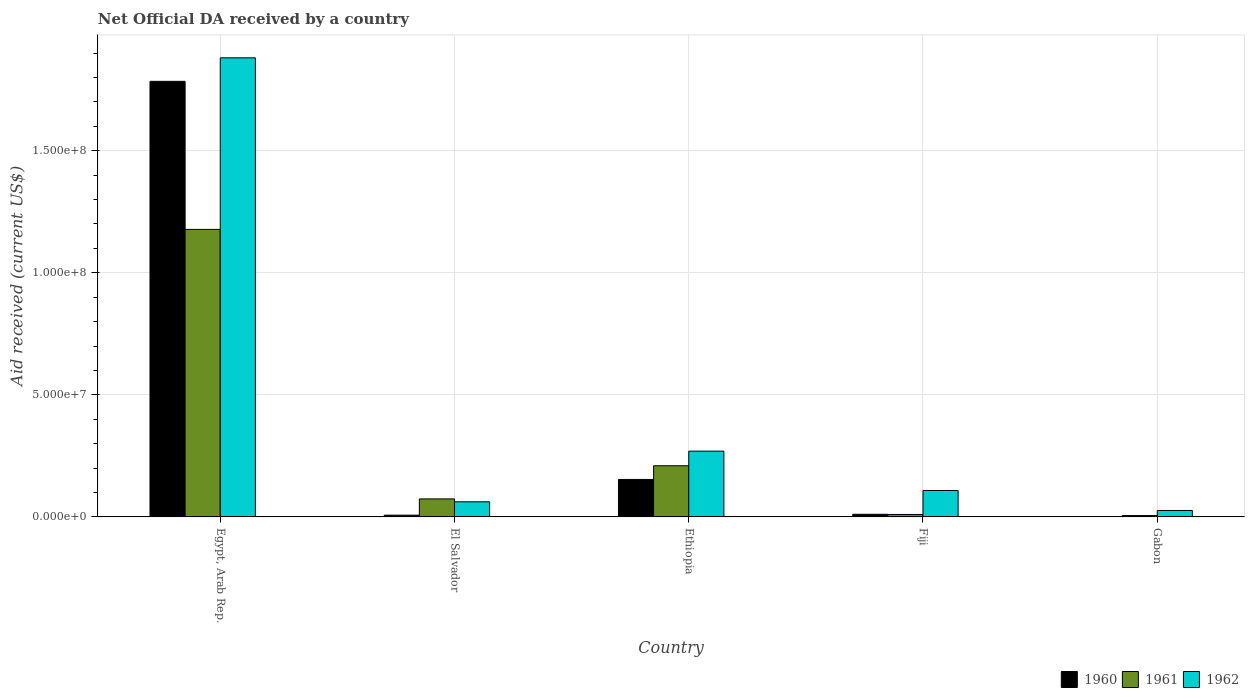Are the number of bars per tick equal to the number of legend labels?
Your answer should be compact. Yes. Are the number of bars on each tick of the X-axis equal?
Make the answer very short. Yes. How many bars are there on the 1st tick from the left?
Your response must be concise. 3. How many bars are there on the 5th tick from the right?
Your answer should be compact. 3. What is the label of the 5th group of bars from the left?
Make the answer very short. Gabon. In how many cases, is the number of bars for a given country not equal to the number of legend labels?
Provide a succinct answer. 0. What is the net official development assistance aid received in 1960 in Ethiopia?
Provide a short and direct response. 1.54e+07. Across all countries, what is the maximum net official development assistance aid received in 1960?
Provide a succinct answer. 1.78e+08. Across all countries, what is the minimum net official development assistance aid received in 1962?
Ensure brevity in your answer.  2.64e+06. In which country was the net official development assistance aid received in 1962 maximum?
Ensure brevity in your answer.  Egypt, Arab Rep. In which country was the net official development assistance aid received in 1960 minimum?
Your answer should be very brief. Gabon. What is the total net official development assistance aid received in 1961 in the graph?
Your answer should be compact. 1.48e+08. What is the difference between the net official development assistance aid received in 1961 in El Salvador and that in Ethiopia?
Your answer should be very brief. -1.36e+07. What is the difference between the net official development assistance aid received in 1960 in Gabon and the net official development assistance aid received in 1962 in El Salvador?
Provide a succinct answer. -6.17e+06. What is the average net official development assistance aid received in 1960 per country?
Give a very brief answer. 3.91e+07. What is the difference between the net official development assistance aid received of/in 1962 and net official development assistance aid received of/in 1960 in Ethiopia?
Your answer should be compact. 1.16e+07. What is the ratio of the net official development assistance aid received in 1962 in El Salvador to that in Ethiopia?
Your response must be concise. 0.23. Is the net official development assistance aid received in 1960 in Egypt, Arab Rep. less than that in Ethiopia?
Keep it short and to the point. No. What is the difference between the highest and the second highest net official development assistance aid received in 1960?
Give a very brief answer. 1.77e+08. What is the difference between the highest and the lowest net official development assistance aid received in 1962?
Offer a very short reply. 1.85e+08. In how many countries, is the net official development assistance aid received in 1960 greater than the average net official development assistance aid received in 1960 taken over all countries?
Ensure brevity in your answer.  1. What does the 2nd bar from the left in Ethiopia represents?
Keep it short and to the point. 1961. Is it the case that in every country, the sum of the net official development assistance aid received in 1961 and net official development assistance aid received in 1962 is greater than the net official development assistance aid received in 1960?
Your response must be concise. Yes. How many bars are there?
Keep it short and to the point. 15. Are all the bars in the graph horizontal?
Your answer should be compact. No. How many countries are there in the graph?
Make the answer very short. 5. Where does the legend appear in the graph?
Offer a terse response. Bottom right. How are the legend labels stacked?
Ensure brevity in your answer.  Horizontal. What is the title of the graph?
Make the answer very short. Net Official DA received by a country. What is the label or title of the Y-axis?
Provide a succinct answer. Aid received (current US$). What is the Aid received (current US$) of 1960 in Egypt, Arab Rep.?
Ensure brevity in your answer.  1.78e+08. What is the Aid received (current US$) of 1961 in Egypt, Arab Rep.?
Provide a succinct answer. 1.18e+08. What is the Aid received (current US$) of 1962 in Egypt, Arab Rep.?
Provide a succinct answer. 1.88e+08. What is the Aid received (current US$) in 1960 in El Salvador?
Make the answer very short. 7.20e+05. What is the Aid received (current US$) of 1961 in El Salvador?
Your answer should be compact. 7.38e+06. What is the Aid received (current US$) of 1962 in El Salvador?
Keep it short and to the point. 6.19e+06. What is the Aid received (current US$) of 1960 in Ethiopia?
Provide a succinct answer. 1.54e+07. What is the Aid received (current US$) in 1961 in Ethiopia?
Keep it short and to the point. 2.10e+07. What is the Aid received (current US$) in 1962 in Ethiopia?
Keep it short and to the point. 2.69e+07. What is the Aid received (current US$) of 1960 in Fiji?
Keep it short and to the point. 1.08e+06. What is the Aid received (current US$) of 1961 in Fiji?
Ensure brevity in your answer.  1.01e+06. What is the Aid received (current US$) in 1962 in Fiji?
Keep it short and to the point. 1.08e+07. What is the Aid received (current US$) of 1960 in Gabon?
Give a very brief answer. 2.00e+04. What is the Aid received (current US$) in 1961 in Gabon?
Offer a very short reply. 5.60e+05. What is the Aid received (current US$) of 1962 in Gabon?
Your answer should be compact. 2.64e+06. Across all countries, what is the maximum Aid received (current US$) in 1960?
Ensure brevity in your answer.  1.78e+08. Across all countries, what is the maximum Aid received (current US$) in 1961?
Provide a succinct answer. 1.18e+08. Across all countries, what is the maximum Aid received (current US$) in 1962?
Offer a terse response. 1.88e+08. Across all countries, what is the minimum Aid received (current US$) of 1960?
Keep it short and to the point. 2.00e+04. Across all countries, what is the minimum Aid received (current US$) of 1961?
Make the answer very short. 5.60e+05. Across all countries, what is the minimum Aid received (current US$) in 1962?
Your answer should be compact. 2.64e+06. What is the total Aid received (current US$) in 1960 in the graph?
Your answer should be very brief. 1.96e+08. What is the total Aid received (current US$) of 1961 in the graph?
Give a very brief answer. 1.48e+08. What is the total Aid received (current US$) of 1962 in the graph?
Provide a short and direct response. 2.35e+08. What is the difference between the Aid received (current US$) of 1960 in Egypt, Arab Rep. and that in El Salvador?
Give a very brief answer. 1.78e+08. What is the difference between the Aid received (current US$) in 1961 in Egypt, Arab Rep. and that in El Salvador?
Your answer should be compact. 1.10e+08. What is the difference between the Aid received (current US$) in 1962 in Egypt, Arab Rep. and that in El Salvador?
Provide a short and direct response. 1.82e+08. What is the difference between the Aid received (current US$) in 1960 in Egypt, Arab Rep. and that in Ethiopia?
Give a very brief answer. 1.63e+08. What is the difference between the Aid received (current US$) of 1961 in Egypt, Arab Rep. and that in Ethiopia?
Ensure brevity in your answer.  9.68e+07. What is the difference between the Aid received (current US$) in 1962 in Egypt, Arab Rep. and that in Ethiopia?
Keep it short and to the point. 1.61e+08. What is the difference between the Aid received (current US$) of 1960 in Egypt, Arab Rep. and that in Fiji?
Provide a short and direct response. 1.77e+08. What is the difference between the Aid received (current US$) of 1961 in Egypt, Arab Rep. and that in Fiji?
Offer a very short reply. 1.17e+08. What is the difference between the Aid received (current US$) of 1962 in Egypt, Arab Rep. and that in Fiji?
Keep it short and to the point. 1.77e+08. What is the difference between the Aid received (current US$) of 1960 in Egypt, Arab Rep. and that in Gabon?
Your response must be concise. 1.78e+08. What is the difference between the Aid received (current US$) of 1961 in Egypt, Arab Rep. and that in Gabon?
Make the answer very short. 1.17e+08. What is the difference between the Aid received (current US$) of 1962 in Egypt, Arab Rep. and that in Gabon?
Keep it short and to the point. 1.85e+08. What is the difference between the Aid received (current US$) in 1960 in El Salvador and that in Ethiopia?
Your response must be concise. -1.46e+07. What is the difference between the Aid received (current US$) of 1961 in El Salvador and that in Ethiopia?
Offer a terse response. -1.36e+07. What is the difference between the Aid received (current US$) in 1962 in El Salvador and that in Ethiopia?
Ensure brevity in your answer.  -2.08e+07. What is the difference between the Aid received (current US$) in 1960 in El Salvador and that in Fiji?
Provide a succinct answer. -3.60e+05. What is the difference between the Aid received (current US$) of 1961 in El Salvador and that in Fiji?
Give a very brief answer. 6.37e+06. What is the difference between the Aid received (current US$) of 1962 in El Salvador and that in Fiji?
Ensure brevity in your answer.  -4.63e+06. What is the difference between the Aid received (current US$) in 1960 in El Salvador and that in Gabon?
Your answer should be compact. 7.00e+05. What is the difference between the Aid received (current US$) of 1961 in El Salvador and that in Gabon?
Make the answer very short. 6.82e+06. What is the difference between the Aid received (current US$) in 1962 in El Salvador and that in Gabon?
Provide a short and direct response. 3.55e+06. What is the difference between the Aid received (current US$) in 1960 in Ethiopia and that in Fiji?
Make the answer very short. 1.43e+07. What is the difference between the Aid received (current US$) of 1961 in Ethiopia and that in Fiji?
Your answer should be very brief. 2.00e+07. What is the difference between the Aid received (current US$) in 1962 in Ethiopia and that in Fiji?
Make the answer very short. 1.61e+07. What is the difference between the Aid received (current US$) of 1960 in Ethiopia and that in Gabon?
Your response must be concise. 1.53e+07. What is the difference between the Aid received (current US$) in 1961 in Ethiopia and that in Gabon?
Keep it short and to the point. 2.04e+07. What is the difference between the Aid received (current US$) of 1962 in Ethiopia and that in Gabon?
Your answer should be compact. 2.43e+07. What is the difference between the Aid received (current US$) of 1960 in Fiji and that in Gabon?
Provide a short and direct response. 1.06e+06. What is the difference between the Aid received (current US$) of 1962 in Fiji and that in Gabon?
Give a very brief answer. 8.18e+06. What is the difference between the Aid received (current US$) in 1960 in Egypt, Arab Rep. and the Aid received (current US$) in 1961 in El Salvador?
Provide a short and direct response. 1.71e+08. What is the difference between the Aid received (current US$) in 1960 in Egypt, Arab Rep. and the Aid received (current US$) in 1962 in El Salvador?
Offer a terse response. 1.72e+08. What is the difference between the Aid received (current US$) in 1961 in Egypt, Arab Rep. and the Aid received (current US$) in 1962 in El Salvador?
Provide a succinct answer. 1.12e+08. What is the difference between the Aid received (current US$) in 1960 in Egypt, Arab Rep. and the Aid received (current US$) in 1961 in Ethiopia?
Offer a terse response. 1.57e+08. What is the difference between the Aid received (current US$) of 1960 in Egypt, Arab Rep. and the Aid received (current US$) of 1962 in Ethiopia?
Ensure brevity in your answer.  1.51e+08. What is the difference between the Aid received (current US$) of 1961 in Egypt, Arab Rep. and the Aid received (current US$) of 1962 in Ethiopia?
Offer a very short reply. 9.08e+07. What is the difference between the Aid received (current US$) of 1960 in Egypt, Arab Rep. and the Aid received (current US$) of 1961 in Fiji?
Keep it short and to the point. 1.77e+08. What is the difference between the Aid received (current US$) of 1960 in Egypt, Arab Rep. and the Aid received (current US$) of 1962 in Fiji?
Ensure brevity in your answer.  1.68e+08. What is the difference between the Aid received (current US$) of 1961 in Egypt, Arab Rep. and the Aid received (current US$) of 1962 in Fiji?
Keep it short and to the point. 1.07e+08. What is the difference between the Aid received (current US$) of 1960 in Egypt, Arab Rep. and the Aid received (current US$) of 1961 in Gabon?
Your answer should be very brief. 1.78e+08. What is the difference between the Aid received (current US$) in 1960 in Egypt, Arab Rep. and the Aid received (current US$) in 1962 in Gabon?
Provide a succinct answer. 1.76e+08. What is the difference between the Aid received (current US$) of 1961 in Egypt, Arab Rep. and the Aid received (current US$) of 1962 in Gabon?
Keep it short and to the point. 1.15e+08. What is the difference between the Aid received (current US$) of 1960 in El Salvador and the Aid received (current US$) of 1961 in Ethiopia?
Offer a terse response. -2.02e+07. What is the difference between the Aid received (current US$) in 1960 in El Salvador and the Aid received (current US$) in 1962 in Ethiopia?
Your answer should be compact. -2.62e+07. What is the difference between the Aid received (current US$) in 1961 in El Salvador and the Aid received (current US$) in 1962 in Ethiopia?
Offer a terse response. -1.96e+07. What is the difference between the Aid received (current US$) in 1960 in El Salvador and the Aid received (current US$) in 1962 in Fiji?
Provide a short and direct response. -1.01e+07. What is the difference between the Aid received (current US$) of 1961 in El Salvador and the Aid received (current US$) of 1962 in Fiji?
Offer a terse response. -3.44e+06. What is the difference between the Aid received (current US$) of 1960 in El Salvador and the Aid received (current US$) of 1962 in Gabon?
Keep it short and to the point. -1.92e+06. What is the difference between the Aid received (current US$) of 1961 in El Salvador and the Aid received (current US$) of 1962 in Gabon?
Offer a terse response. 4.74e+06. What is the difference between the Aid received (current US$) of 1960 in Ethiopia and the Aid received (current US$) of 1961 in Fiji?
Offer a terse response. 1.43e+07. What is the difference between the Aid received (current US$) in 1960 in Ethiopia and the Aid received (current US$) in 1962 in Fiji?
Your answer should be compact. 4.53e+06. What is the difference between the Aid received (current US$) of 1961 in Ethiopia and the Aid received (current US$) of 1962 in Fiji?
Give a very brief answer. 1.01e+07. What is the difference between the Aid received (current US$) of 1960 in Ethiopia and the Aid received (current US$) of 1961 in Gabon?
Ensure brevity in your answer.  1.48e+07. What is the difference between the Aid received (current US$) of 1960 in Ethiopia and the Aid received (current US$) of 1962 in Gabon?
Ensure brevity in your answer.  1.27e+07. What is the difference between the Aid received (current US$) of 1961 in Ethiopia and the Aid received (current US$) of 1962 in Gabon?
Your response must be concise. 1.83e+07. What is the difference between the Aid received (current US$) in 1960 in Fiji and the Aid received (current US$) in 1961 in Gabon?
Offer a very short reply. 5.20e+05. What is the difference between the Aid received (current US$) in 1960 in Fiji and the Aid received (current US$) in 1962 in Gabon?
Provide a short and direct response. -1.56e+06. What is the difference between the Aid received (current US$) in 1961 in Fiji and the Aid received (current US$) in 1962 in Gabon?
Offer a terse response. -1.63e+06. What is the average Aid received (current US$) of 1960 per country?
Ensure brevity in your answer.  3.91e+07. What is the average Aid received (current US$) in 1961 per country?
Offer a terse response. 2.95e+07. What is the average Aid received (current US$) of 1962 per country?
Your response must be concise. 4.69e+07. What is the difference between the Aid received (current US$) in 1960 and Aid received (current US$) in 1961 in Egypt, Arab Rep.?
Give a very brief answer. 6.06e+07. What is the difference between the Aid received (current US$) in 1960 and Aid received (current US$) in 1962 in Egypt, Arab Rep.?
Ensure brevity in your answer.  -9.63e+06. What is the difference between the Aid received (current US$) in 1961 and Aid received (current US$) in 1962 in Egypt, Arab Rep.?
Make the answer very short. -7.03e+07. What is the difference between the Aid received (current US$) in 1960 and Aid received (current US$) in 1961 in El Salvador?
Give a very brief answer. -6.66e+06. What is the difference between the Aid received (current US$) of 1960 and Aid received (current US$) of 1962 in El Salvador?
Provide a short and direct response. -5.47e+06. What is the difference between the Aid received (current US$) of 1961 and Aid received (current US$) of 1962 in El Salvador?
Offer a terse response. 1.19e+06. What is the difference between the Aid received (current US$) in 1960 and Aid received (current US$) in 1961 in Ethiopia?
Make the answer very short. -5.61e+06. What is the difference between the Aid received (current US$) in 1960 and Aid received (current US$) in 1962 in Ethiopia?
Provide a short and direct response. -1.16e+07. What is the difference between the Aid received (current US$) of 1961 and Aid received (current US$) of 1962 in Ethiopia?
Keep it short and to the point. -5.98e+06. What is the difference between the Aid received (current US$) in 1960 and Aid received (current US$) in 1962 in Fiji?
Give a very brief answer. -9.74e+06. What is the difference between the Aid received (current US$) in 1961 and Aid received (current US$) in 1962 in Fiji?
Provide a short and direct response. -9.81e+06. What is the difference between the Aid received (current US$) of 1960 and Aid received (current US$) of 1961 in Gabon?
Your answer should be compact. -5.40e+05. What is the difference between the Aid received (current US$) in 1960 and Aid received (current US$) in 1962 in Gabon?
Keep it short and to the point. -2.62e+06. What is the difference between the Aid received (current US$) of 1961 and Aid received (current US$) of 1962 in Gabon?
Ensure brevity in your answer.  -2.08e+06. What is the ratio of the Aid received (current US$) in 1960 in Egypt, Arab Rep. to that in El Salvador?
Keep it short and to the point. 247.79. What is the ratio of the Aid received (current US$) of 1961 in Egypt, Arab Rep. to that in El Salvador?
Provide a succinct answer. 15.96. What is the ratio of the Aid received (current US$) of 1962 in Egypt, Arab Rep. to that in El Salvador?
Keep it short and to the point. 30.38. What is the ratio of the Aid received (current US$) in 1960 in Egypt, Arab Rep. to that in Ethiopia?
Give a very brief answer. 11.62. What is the ratio of the Aid received (current US$) of 1961 in Egypt, Arab Rep. to that in Ethiopia?
Keep it short and to the point. 5.62. What is the ratio of the Aid received (current US$) of 1962 in Egypt, Arab Rep. to that in Ethiopia?
Ensure brevity in your answer.  6.98. What is the ratio of the Aid received (current US$) of 1960 in Egypt, Arab Rep. to that in Fiji?
Your answer should be very brief. 165.19. What is the ratio of the Aid received (current US$) in 1961 in Egypt, Arab Rep. to that in Fiji?
Offer a very short reply. 116.6. What is the ratio of the Aid received (current US$) of 1962 in Egypt, Arab Rep. to that in Fiji?
Ensure brevity in your answer.  17.38. What is the ratio of the Aid received (current US$) of 1960 in Egypt, Arab Rep. to that in Gabon?
Provide a succinct answer. 8920.5. What is the ratio of the Aid received (current US$) of 1961 in Egypt, Arab Rep. to that in Gabon?
Provide a succinct answer. 210.3. What is the ratio of the Aid received (current US$) of 1962 in Egypt, Arab Rep. to that in Gabon?
Provide a short and direct response. 71.23. What is the ratio of the Aid received (current US$) of 1960 in El Salvador to that in Ethiopia?
Give a very brief answer. 0.05. What is the ratio of the Aid received (current US$) of 1961 in El Salvador to that in Ethiopia?
Your answer should be very brief. 0.35. What is the ratio of the Aid received (current US$) of 1962 in El Salvador to that in Ethiopia?
Give a very brief answer. 0.23. What is the ratio of the Aid received (current US$) in 1960 in El Salvador to that in Fiji?
Provide a short and direct response. 0.67. What is the ratio of the Aid received (current US$) in 1961 in El Salvador to that in Fiji?
Provide a succinct answer. 7.31. What is the ratio of the Aid received (current US$) in 1962 in El Salvador to that in Fiji?
Your response must be concise. 0.57. What is the ratio of the Aid received (current US$) of 1961 in El Salvador to that in Gabon?
Offer a very short reply. 13.18. What is the ratio of the Aid received (current US$) in 1962 in El Salvador to that in Gabon?
Offer a very short reply. 2.34. What is the ratio of the Aid received (current US$) in 1960 in Ethiopia to that in Fiji?
Your answer should be compact. 14.21. What is the ratio of the Aid received (current US$) in 1961 in Ethiopia to that in Fiji?
Your response must be concise. 20.75. What is the ratio of the Aid received (current US$) in 1962 in Ethiopia to that in Fiji?
Make the answer very short. 2.49. What is the ratio of the Aid received (current US$) of 1960 in Ethiopia to that in Gabon?
Your answer should be compact. 767.5. What is the ratio of the Aid received (current US$) of 1961 in Ethiopia to that in Gabon?
Ensure brevity in your answer.  37.43. What is the ratio of the Aid received (current US$) in 1962 in Ethiopia to that in Gabon?
Your response must be concise. 10.2. What is the ratio of the Aid received (current US$) in 1961 in Fiji to that in Gabon?
Keep it short and to the point. 1.8. What is the ratio of the Aid received (current US$) in 1962 in Fiji to that in Gabon?
Keep it short and to the point. 4.1. What is the difference between the highest and the second highest Aid received (current US$) of 1960?
Give a very brief answer. 1.63e+08. What is the difference between the highest and the second highest Aid received (current US$) in 1961?
Offer a very short reply. 9.68e+07. What is the difference between the highest and the second highest Aid received (current US$) in 1962?
Your response must be concise. 1.61e+08. What is the difference between the highest and the lowest Aid received (current US$) in 1960?
Your response must be concise. 1.78e+08. What is the difference between the highest and the lowest Aid received (current US$) of 1961?
Your answer should be very brief. 1.17e+08. What is the difference between the highest and the lowest Aid received (current US$) of 1962?
Your answer should be very brief. 1.85e+08. 